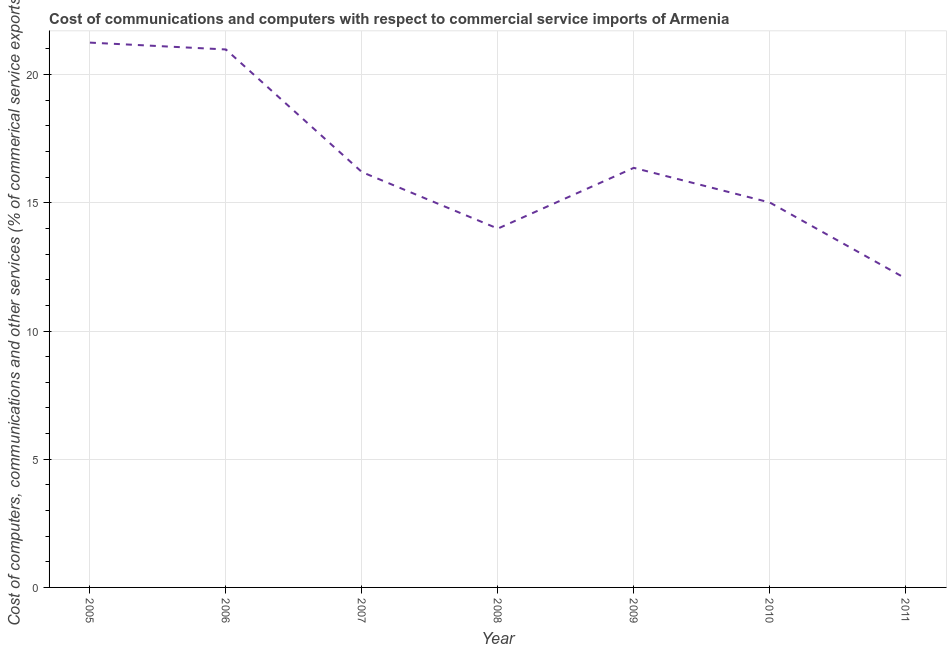What is the cost of communications in 2011?
Provide a short and direct response. 12.05. Across all years, what is the maximum  computer and other services?
Offer a terse response. 21.25. Across all years, what is the minimum cost of communications?
Make the answer very short. 12.05. In which year was the  computer and other services minimum?
Your answer should be compact. 2011. What is the sum of the cost of communications?
Make the answer very short. 115.85. What is the difference between the cost of communications in 2005 and 2009?
Your answer should be compact. 4.88. What is the average  computer and other services per year?
Make the answer very short. 16.55. What is the median cost of communications?
Keep it short and to the point. 16.2. Do a majority of the years between 2005 and 2007 (inclusive) have  computer and other services greater than 18 %?
Provide a succinct answer. Yes. What is the ratio of the  computer and other services in 2005 to that in 2006?
Your answer should be very brief. 1.01. Is the difference between the cost of communications in 2008 and 2010 greater than the difference between any two years?
Offer a terse response. No. What is the difference between the highest and the second highest  computer and other services?
Offer a very short reply. 0.27. Is the sum of the  computer and other services in 2005 and 2007 greater than the maximum  computer and other services across all years?
Your answer should be compact. Yes. What is the difference between the highest and the lowest  computer and other services?
Your answer should be compact. 9.2. Does the cost of communications monotonically increase over the years?
Keep it short and to the point. No. How many lines are there?
Offer a very short reply. 1. How many years are there in the graph?
Make the answer very short. 7. What is the difference between two consecutive major ticks on the Y-axis?
Make the answer very short. 5. Does the graph contain any zero values?
Ensure brevity in your answer.  No. What is the title of the graph?
Offer a very short reply. Cost of communications and computers with respect to commercial service imports of Armenia. What is the label or title of the X-axis?
Your answer should be very brief. Year. What is the label or title of the Y-axis?
Offer a very short reply. Cost of computers, communications and other services (% of commerical service exports). What is the Cost of computers, communications and other services (% of commerical service exports) in 2005?
Your answer should be very brief. 21.25. What is the Cost of computers, communications and other services (% of commerical service exports) in 2006?
Make the answer very short. 20.98. What is the Cost of computers, communications and other services (% of commerical service exports) in 2007?
Provide a succinct answer. 16.2. What is the Cost of computers, communications and other services (% of commerical service exports) in 2008?
Offer a very short reply. 13.99. What is the Cost of computers, communications and other services (% of commerical service exports) of 2009?
Give a very brief answer. 16.36. What is the Cost of computers, communications and other services (% of commerical service exports) of 2010?
Ensure brevity in your answer.  15.01. What is the Cost of computers, communications and other services (% of commerical service exports) of 2011?
Keep it short and to the point. 12.05. What is the difference between the Cost of computers, communications and other services (% of commerical service exports) in 2005 and 2006?
Provide a short and direct response. 0.27. What is the difference between the Cost of computers, communications and other services (% of commerical service exports) in 2005 and 2007?
Offer a terse response. 5.05. What is the difference between the Cost of computers, communications and other services (% of commerical service exports) in 2005 and 2008?
Provide a succinct answer. 7.25. What is the difference between the Cost of computers, communications and other services (% of commerical service exports) in 2005 and 2009?
Make the answer very short. 4.88. What is the difference between the Cost of computers, communications and other services (% of commerical service exports) in 2005 and 2010?
Your response must be concise. 6.23. What is the difference between the Cost of computers, communications and other services (% of commerical service exports) in 2005 and 2011?
Keep it short and to the point. 9.2. What is the difference between the Cost of computers, communications and other services (% of commerical service exports) in 2006 and 2007?
Give a very brief answer. 4.78. What is the difference between the Cost of computers, communications and other services (% of commerical service exports) in 2006 and 2008?
Offer a terse response. 6.99. What is the difference between the Cost of computers, communications and other services (% of commerical service exports) in 2006 and 2009?
Your answer should be very brief. 4.62. What is the difference between the Cost of computers, communications and other services (% of commerical service exports) in 2006 and 2010?
Make the answer very short. 5.97. What is the difference between the Cost of computers, communications and other services (% of commerical service exports) in 2006 and 2011?
Keep it short and to the point. 8.93. What is the difference between the Cost of computers, communications and other services (% of commerical service exports) in 2007 and 2008?
Your answer should be compact. 2.21. What is the difference between the Cost of computers, communications and other services (% of commerical service exports) in 2007 and 2009?
Keep it short and to the point. -0.16. What is the difference between the Cost of computers, communications and other services (% of commerical service exports) in 2007 and 2010?
Your response must be concise. 1.19. What is the difference between the Cost of computers, communications and other services (% of commerical service exports) in 2007 and 2011?
Offer a very short reply. 4.15. What is the difference between the Cost of computers, communications and other services (% of commerical service exports) in 2008 and 2009?
Offer a very short reply. -2.37. What is the difference between the Cost of computers, communications and other services (% of commerical service exports) in 2008 and 2010?
Your response must be concise. -1.02. What is the difference between the Cost of computers, communications and other services (% of commerical service exports) in 2008 and 2011?
Offer a terse response. 1.95. What is the difference between the Cost of computers, communications and other services (% of commerical service exports) in 2009 and 2010?
Your answer should be very brief. 1.35. What is the difference between the Cost of computers, communications and other services (% of commerical service exports) in 2009 and 2011?
Ensure brevity in your answer.  4.31. What is the difference between the Cost of computers, communications and other services (% of commerical service exports) in 2010 and 2011?
Make the answer very short. 2.96. What is the ratio of the Cost of computers, communications and other services (% of commerical service exports) in 2005 to that in 2006?
Give a very brief answer. 1.01. What is the ratio of the Cost of computers, communications and other services (% of commerical service exports) in 2005 to that in 2007?
Your answer should be very brief. 1.31. What is the ratio of the Cost of computers, communications and other services (% of commerical service exports) in 2005 to that in 2008?
Provide a short and direct response. 1.52. What is the ratio of the Cost of computers, communications and other services (% of commerical service exports) in 2005 to that in 2009?
Provide a short and direct response. 1.3. What is the ratio of the Cost of computers, communications and other services (% of commerical service exports) in 2005 to that in 2010?
Offer a very short reply. 1.42. What is the ratio of the Cost of computers, communications and other services (% of commerical service exports) in 2005 to that in 2011?
Provide a short and direct response. 1.76. What is the ratio of the Cost of computers, communications and other services (% of commerical service exports) in 2006 to that in 2007?
Provide a succinct answer. 1.29. What is the ratio of the Cost of computers, communications and other services (% of commerical service exports) in 2006 to that in 2008?
Ensure brevity in your answer.  1.5. What is the ratio of the Cost of computers, communications and other services (% of commerical service exports) in 2006 to that in 2009?
Keep it short and to the point. 1.28. What is the ratio of the Cost of computers, communications and other services (% of commerical service exports) in 2006 to that in 2010?
Provide a short and direct response. 1.4. What is the ratio of the Cost of computers, communications and other services (% of commerical service exports) in 2006 to that in 2011?
Offer a terse response. 1.74. What is the ratio of the Cost of computers, communications and other services (% of commerical service exports) in 2007 to that in 2008?
Your answer should be very brief. 1.16. What is the ratio of the Cost of computers, communications and other services (% of commerical service exports) in 2007 to that in 2010?
Your response must be concise. 1.08. What is the ratio of the Cost of computers, communications and other services (% of commerical service exports) in 2007 to that in 2011?
Keep it short and to the point. 1.34. What is the ratio of the Cost of computers, communications and other services (% of commerical service exports) in 2008 to that in 2009?
Offer a terse response. 0.85. What is the ratio of the Cost of computers, communications and other services (% of commerical service exports) in 2008 to that in 2010?
Provide a short and direct response. 0.93. What is the ratio of the Cost of computers, communications and other services (% of commerical service exports) in 2008 to that in 2011?
Make the answer very short. 1.16. What is the ratio of the Cost of computers, communications and other services (% of commerical service exports) in 2009 to that in 2010?
Offer a very short reply. 1.09. What is the ratio of the Cost of computers, communications and other services (% of commerical service exports) in 2009 to that in 2011?
Keep it short and to the point. 1.36. What is the ratio of the Cost of computers, communications and other services (% of commerical service exports) in 2010 to that in 2011?
Provide a short and direct response. 1.25. 